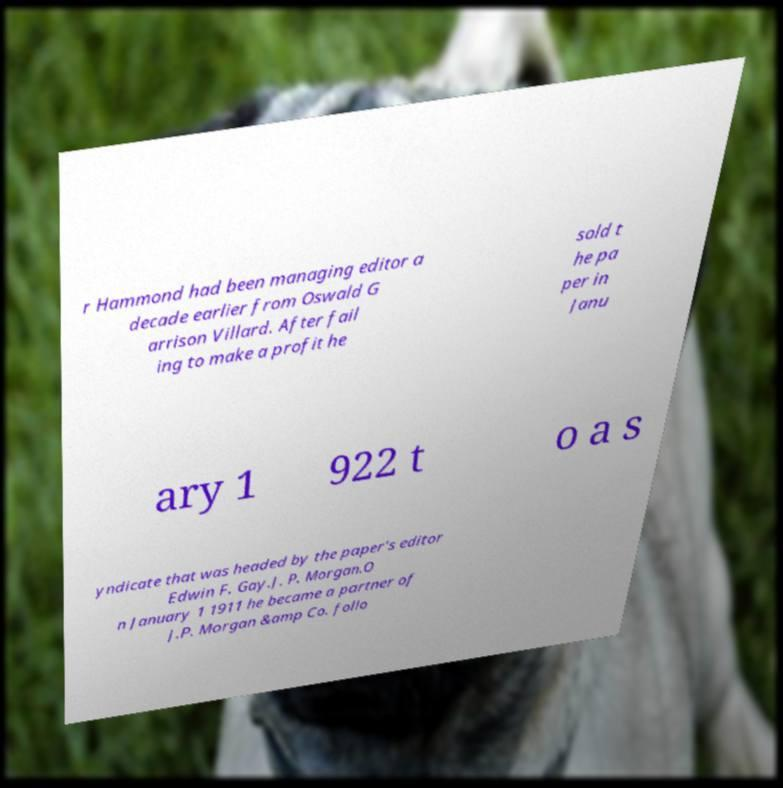Could you assist in decoding the text presented in this image and type it out clearly? r Hammond had been managing editor a decade earlier from Oswald G arrison Villard. After fail ing to make a profit he sold t he pa per in Janu ary 1 922 t o a s yndicate that was headed by the paper's editor Edwin F. Gay.J. P. Morgan.O n January 1 1911 he became a partner of J.P. Morgan &amp Co. follo 